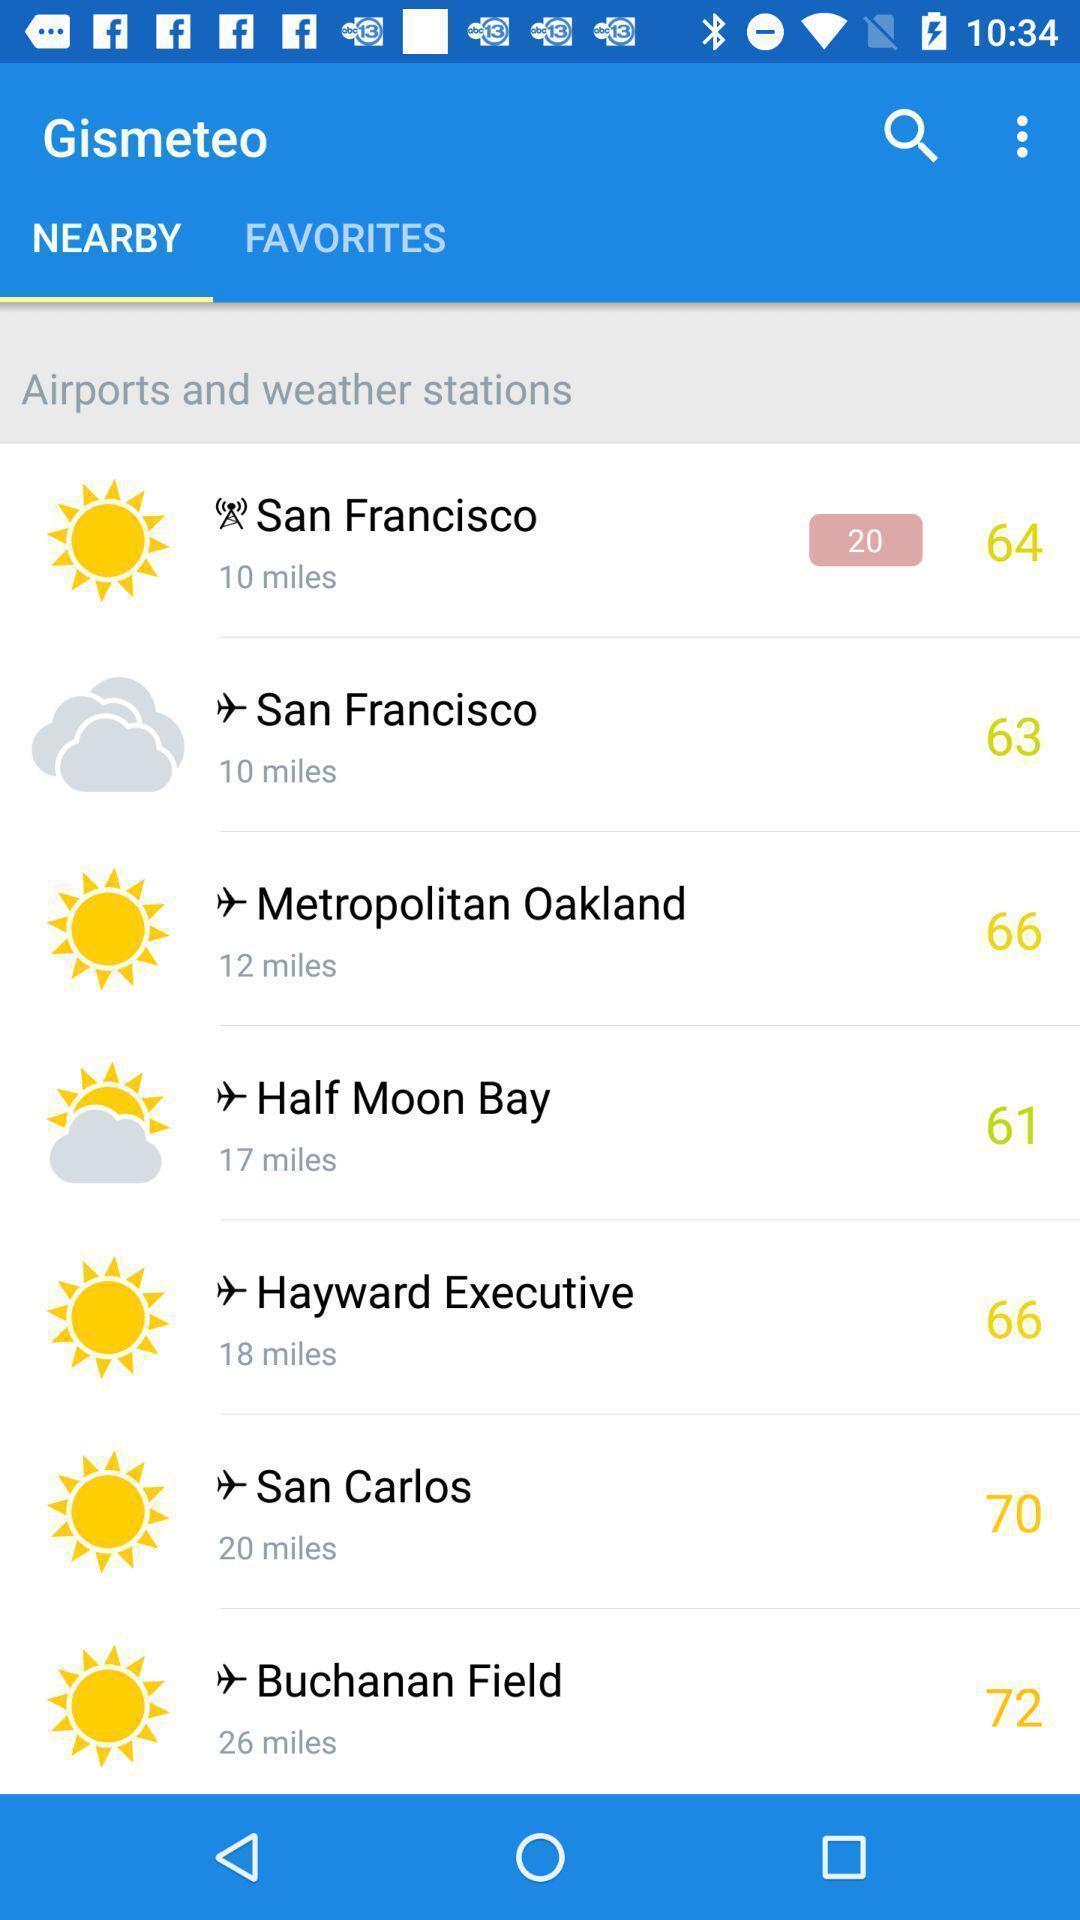What can you discern from this picture? Screen displaying a list of airports and weather station names. 